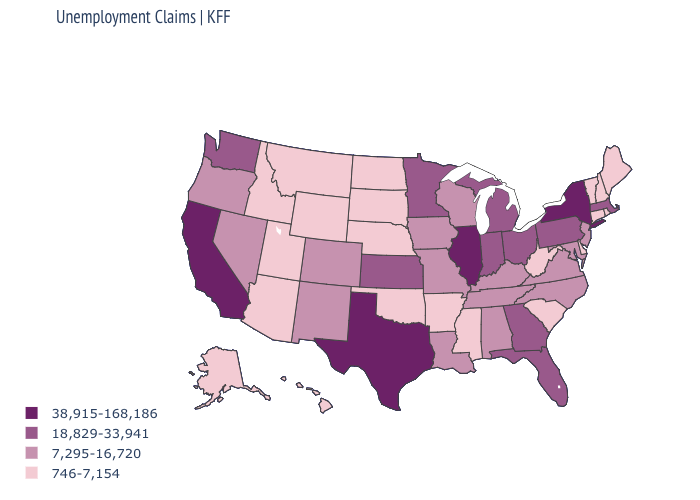What is the lowest value in the USA?
Be succinct. 746-7,154. What is the lowest value in states that border Idaho?
Keep it brief. 746-7,154. What is the value of South Dakota?
Write a very short answer. 746-7,154. Name the states that have a value in the range 746-7,154?
Short answer required. Alaska, Arizona, Arkansas, Connecticut, Delaware, Hawaii, Idaho, Maine, Mississippi, Montana, Nebraska, New Hampshire, North Dakota, Oklahoma, Rhode Island, South Carolina, South Dakota, Utah, Vermont, West Virginia, Wyoming. What is the value of New Hampshire?
Give a very brief answer. 746-7,154. What is the lowest value in states that border Minnesota?
Short answer required. 746-7,154. Which states have the highest value in the USA?
Write a very short answer. California, Illinois, New York, Texas. Does Ohio have a higher value than New York?
Be succinct. No. Which states hav the highest value in the MidWest?
Concise answer only. Illinois. Does Massachusetts have the lowest value in the Northeast?
Answer briefly. No. Among the states that border Colorado , does Kansas have the highest value?
Write a very short answer. Yes. What is the lowest value in the MidWest?
Short answer required. 746-7,154. Which states hav the highest value in the South?
Concise answer only. Texas. What is the value of Wyoming?
Keep it brief. 746-7,154. What is the value of Washington?
Give a very brief answer. 18,829-33,941. 